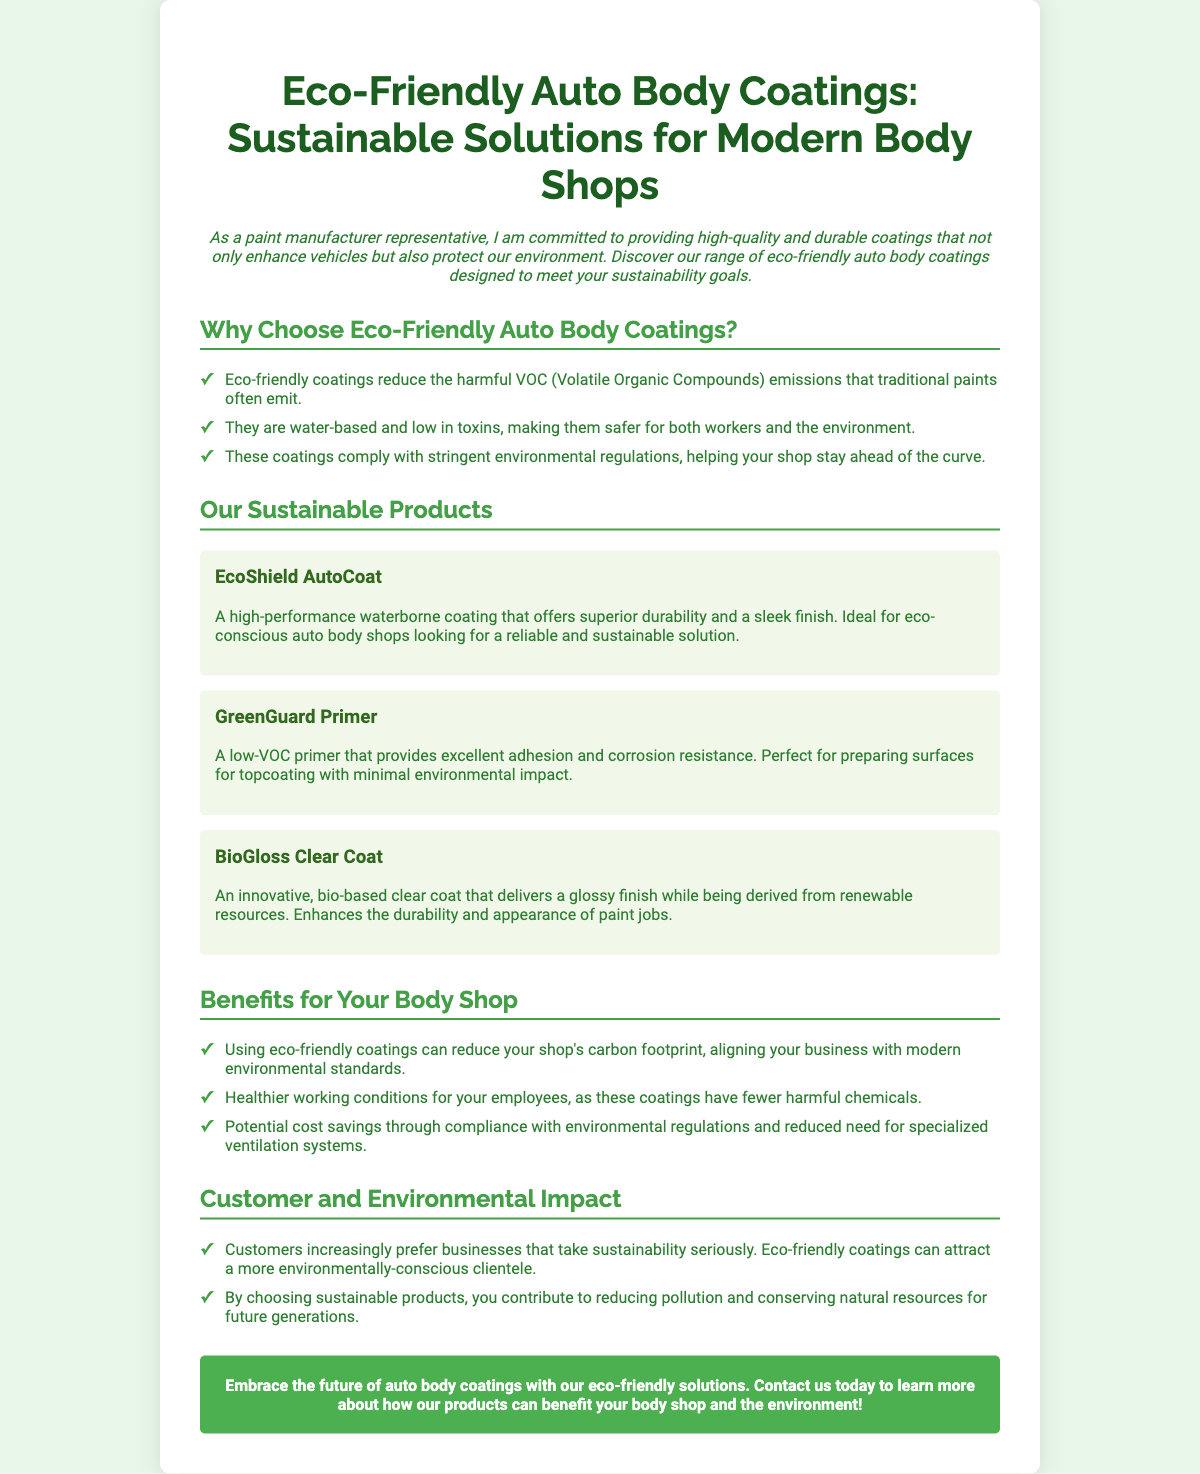What is the title of the flyer? The title is explicitly stated at the top of the document as the main heading.
Answer: Eco-Friendly Auto Body Coatings: Sustainable Solutions for Modern Body Shops What are the three eco-friendly products listed? The flyer provides three specific product names in the "Our Sustainable Products" section.
Answer: EcoShield AutoCoat, GreenGuard Primer, BioGloss Clear Coat What type of emissions do eco-friendly coatings reduce? The document mentions a specific type of emissions that traditional paints emit, which is highlighted.
Answer: VOC (Volatile Organic Compounds) What is one benefit for employees mentioned in the flyer? The benefits section discusses healthier working conditions as a result of using eco-friendly coatings.
Answer: Healthier working conditions What is a unique feature of BioGloss Clear Coat? The flyer describes a particular characteristic that differentiates BioGloss Clear Coat from other products.
Answer: Derived from renewable resources What is the main color scheme used in the flyer? The document contains specific color references that are used throughout the design and text.
Answer: Green and white Why might customers prefer businesses that use eco-friendly coatings? The flyer explains the customer preference linked to sustainability efforts made by businesses.
Answer: Take sustainability seriously How can using eco-friendly products impact a shop's carbon footprint? The document describes a specific positive impact related to emissions when eco-friendly coatings are used.
Answer: Reduce the carbon footprint What action does the flyer encourage readers to take? The closing section of the flyer contains a call to action directed at the audience.
Answer: Contact us today 